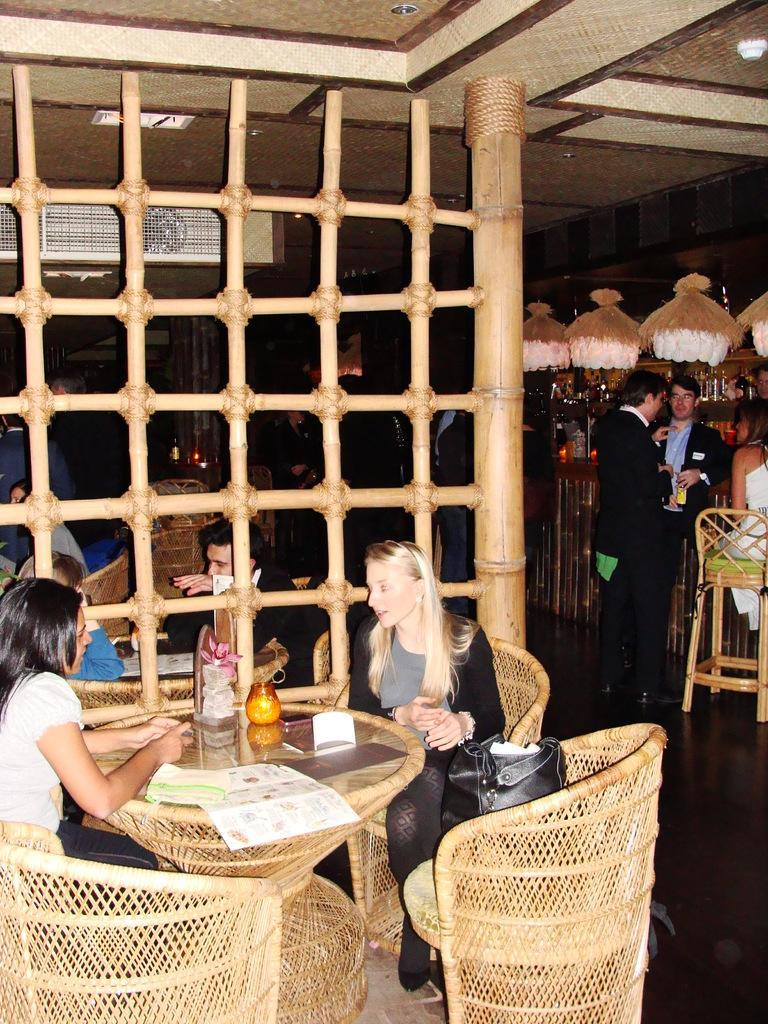Could you give a brief overview of what you see in this image? There are 2 women sitting on the chair at the table. On the table there is a flower vase and papers and we can also handbag on the chair. In the background there is a fence and few people sitting on the chair and other are standing and wine bottles. 